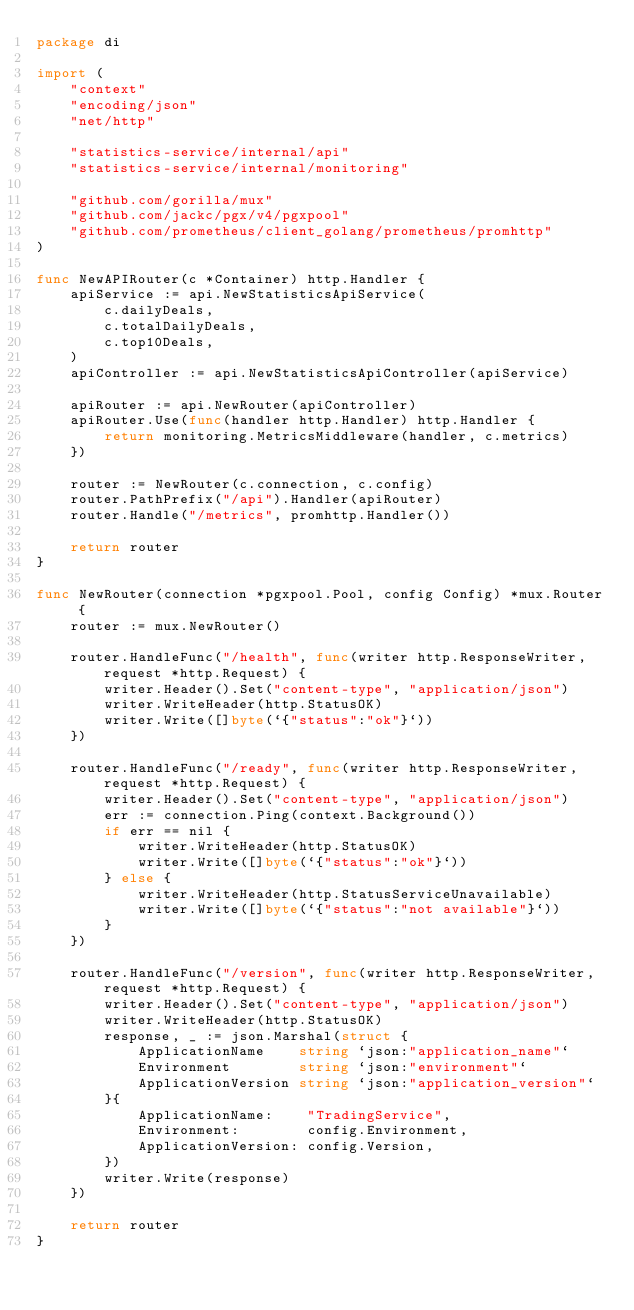<code> <loc_0><loc_0><loc_500><loc_500><_Go_>package di

import (
	"context"
	"encoding/json"
	"net/http"

	"statistics-service/internal/api"
	"statistics-service/internal/monitoring"

	"github.com/gorilla/mux"
	"github.com/jackc/pgx/v4/pgxpool"
	"github.com/prometheus/client_golang/prometheus/promhttp"
)

func NewAPIRouter(c *Container) http.Handler {
	apiService := api.NewStatisticsApiService(
		c.dailyDeals,
		c.totalDailyDeals,
		c.top10Deals,
	)
	apiController := api.NewStatisticsApiController(apiService)

	apiRouter := api.NewRouter(apiController)
	apiRouter.Use(func(handler http.Handler) http.Handler {
		return monitoring.MetricsMiddleware(handler, c.metrics)
	})

	router := NewRouter(c.connection, c.config)
	router.PathPrefix("/api").Handler(apiRouter)
	router.Handle("/metrics", promhttp.Handler())

	return router
}

func NewRouter(connection *pgxpool.Pool, config Config) *mux.Router {
	router := mux.NewRouter()

	router.HandleFunc("/health", func(writer http.ResponseWriter, request *http.Request) {
		writer.Header().Set("content-type", "application/json")
		writer.WriteHeader(http.StatusOK)
		writer.Write([]byte(`{"status":"ok"}`))
	})

	router.HandleFunc("/ready", func(writer http.ResponseWriter, request *http.Request) {
		writer.Header().Set("content-type", "application/json")
		err := connection.Ping(context.Background())
		if err == nil {
			writer.WriteHeader(http.StatusOK)
			writer.Write([]byte(`{"status":"ok"}`))
		} else {
			writer.WriteHeader(http.StatusServiceUnavailable)
			writer.Write([]byte(`{"status":"not available"}`))
		}
	})

	router.HandleFunc("/version", func(writer http.ResponseWriter, request *http.Request) {
		writer.Header().Set("content-type", "application/json")
		writer.WriteHeader(http.StatusOK)
		response, _ := json.Marshal(struct {
			ApplicationName    string `json:"application_name"`
			Environment        string `json:"environment"`
			ApplicationVersion string `json:"application_version"`
		}{
			ApplicationName:    "TradingService",
			Environment:        config.Environment,
			ApplicationVersion: config.Version,
		})
		writer.Write(response)
	})

	return router
}
</code> 